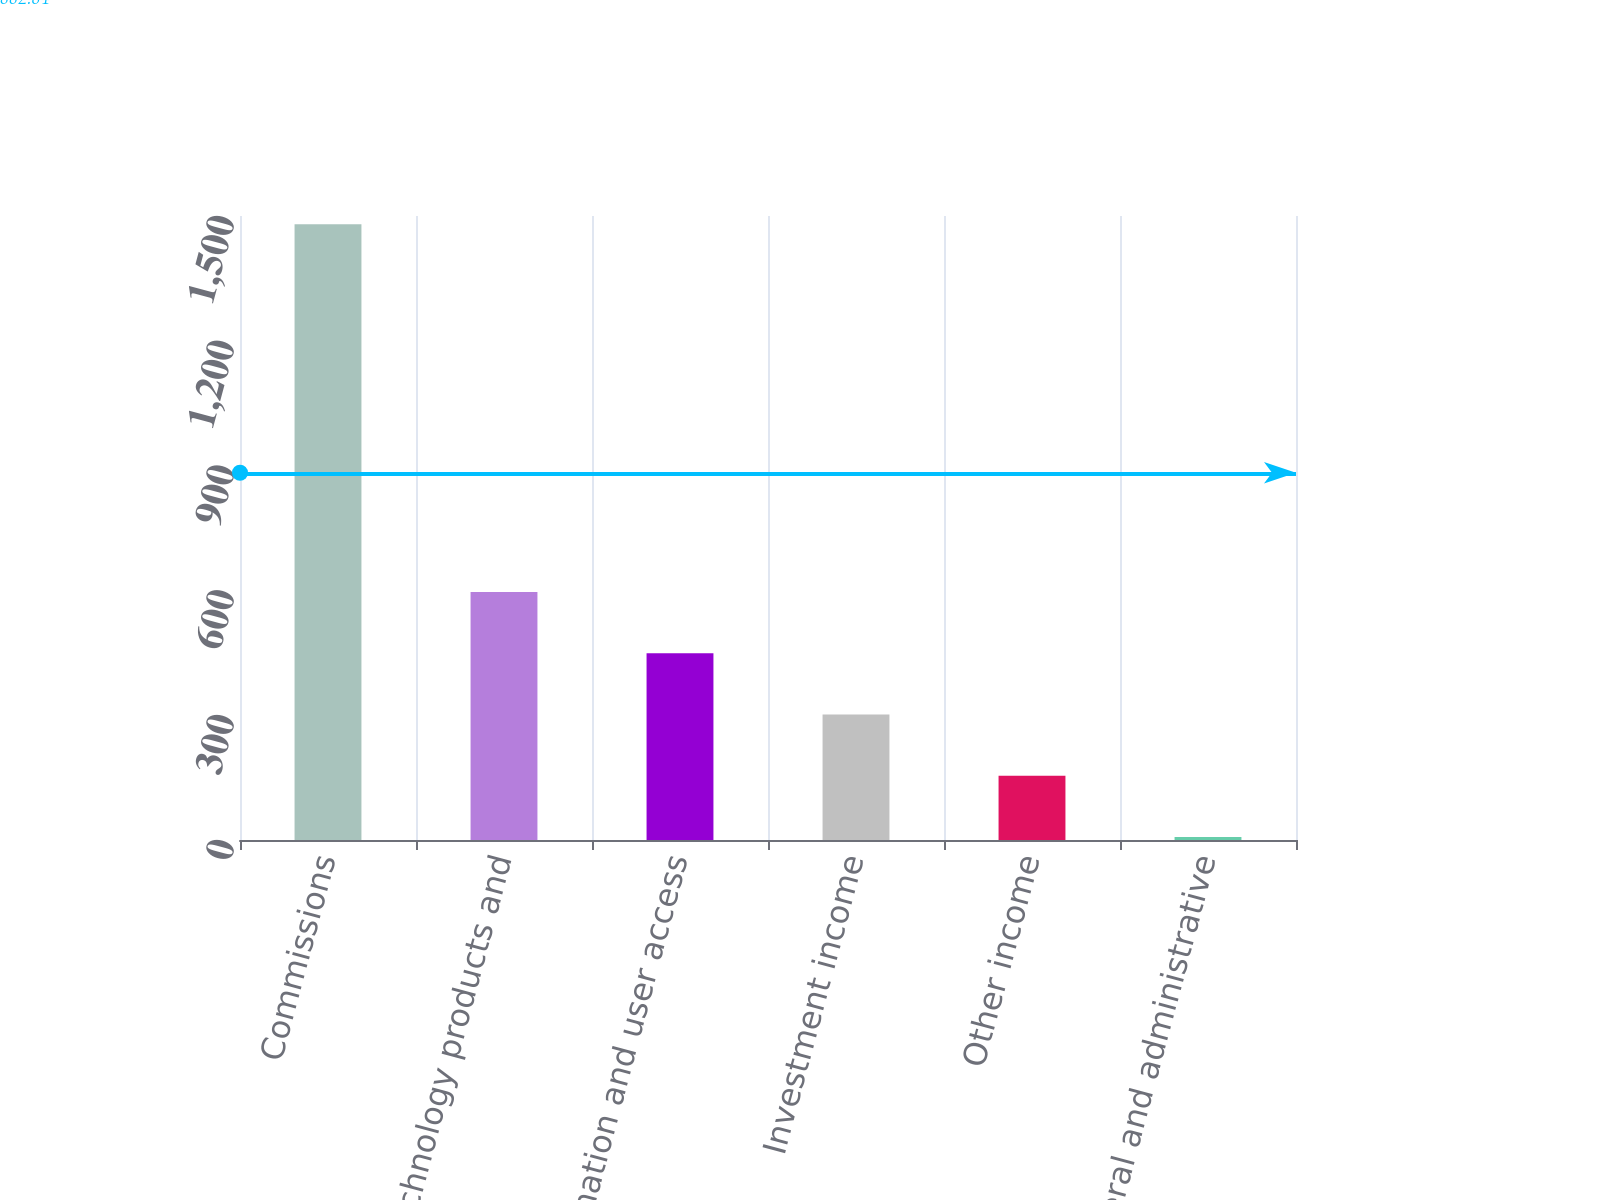Convert chart. <chart><loc_0><loc_0><loc_500><loc_500><bar_chart><fcel>Commissions<fcel>Technology products and<fcel>Information and user access<fcel>Investment income<fcel>Other income<fcel>General and administrative<nl><fcel>1480<fcel>596.2<fcel>448.9<fcel>301.6<fcel>154.3<fcel>7<nl></chart> 